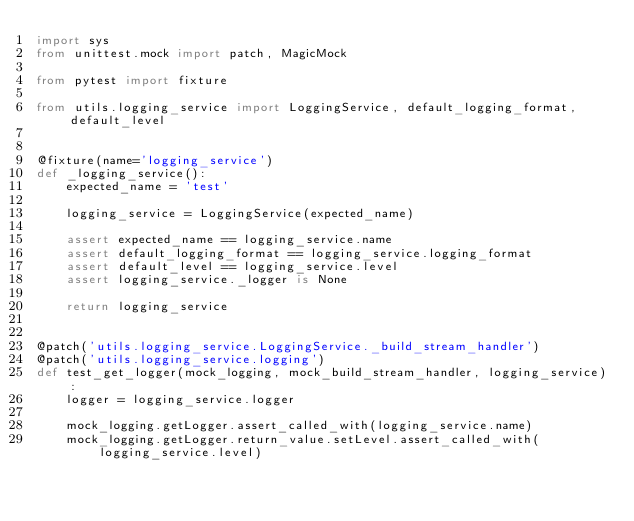Convert code to text. <code><loc_0><loc_0><loc_500><loc_500><_Python_>import sys
from unittest.mock import patch, MagicMock

from pytest import fixture

from utils.logging_service import LoggingService, default_logging_format, default_level


@fixture(name='logging_service')
def _logging_service():
    expected_name = 'test'

    logging_service = LoggingService(expected_name)

    assert expected_name == logging_service.name
    assert default_logging_format == logging_service.logging_format
    assert default_level == logging_service.level
    assert logging_service._logger is None

    return logging_service


@patch('utils.logging_service.LoggingService._build_stream_handler')
@patch('utils.logging_service.logging')
def test_get_logger(mock_logging, mock_build_stream_handler, logging_service):
    logger = logging_service.logger

    mock_logging.getLogger.assert_called_with(logging_service.name)
    mock_logging.getLogger.return_value.setLevel.assert_called_with(logging_service.level)</code> 